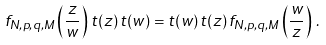<formula> <loc_0><loc_0><loc_500><loc_500>f _ { N , p , q , M } \left ( \frac { z } { w } \right ) \, t ( z ) \, t ( w ) = t ( w ) \, t ( z ) \, f _ { N , p , q , M } \left ( \frac { w } { z } \right ) \, .</formula> 